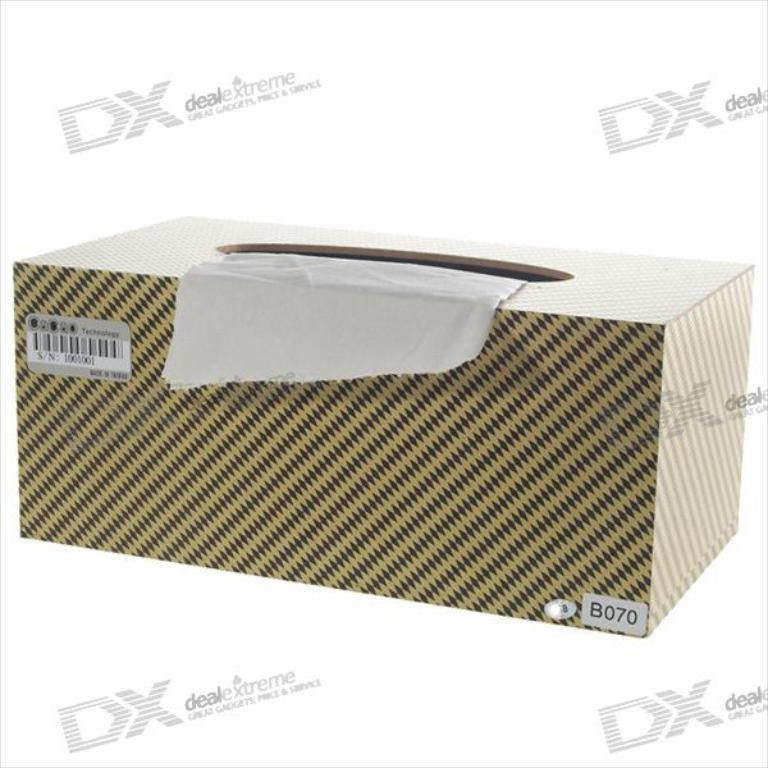What object can be seen in the image? There is a box in the image. What can be observed in the background of the image? There are watermarks in the background of the image. What type of coat is the duck wearing in the image? There are no ducks or coats present in the image. How did the duck get injured, and what is the extent of the wound in the image? There are no ducks or wounds present in the image. 